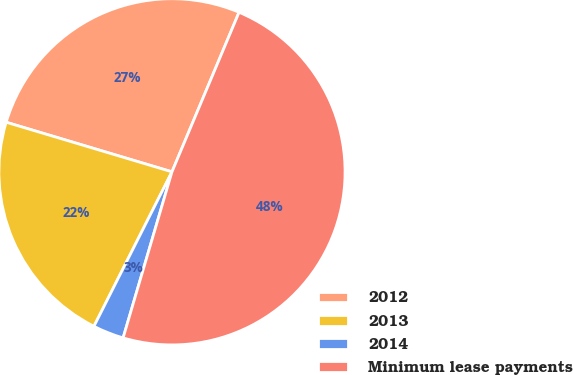Convert chart. <chart><loc_0><loc_0><loc_500><loc_500><pie_chart><fcel>2012<fcel>2013<fcel>2014<fcel>Minimum lease payments<nl><fcel>26.71%<fcel>22.18%<fcel>2.89%<fcel>48.22%<nl></chart> 